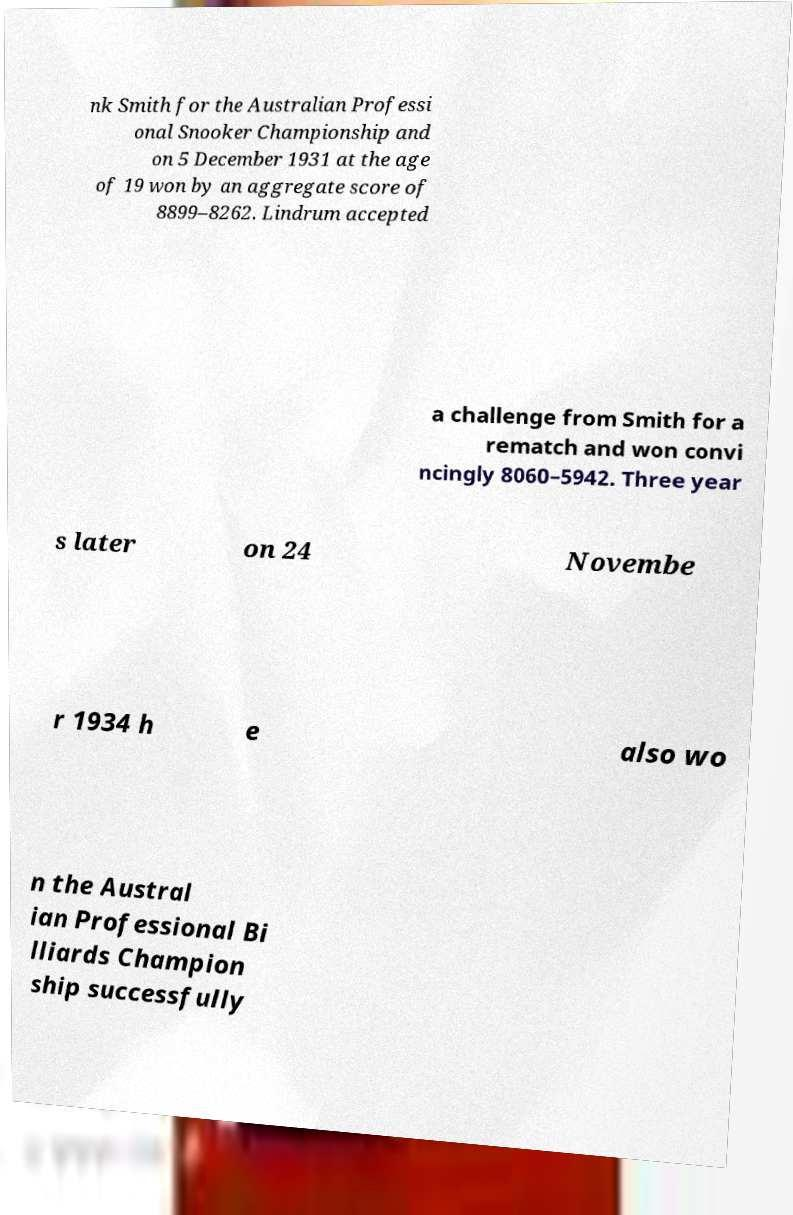Please identify and transcribe the text found in this image. nk Smith for the Australian Professi onal Snooker Championship and on 5 December 1931 at the age of 19 won by an aggregate score of 8899–8262. Lindrum accepted a challenge from Smith for a rematch and won convi ncingly 8060–5942. Three year s later on 24 Novembe r 1934 h e also wo n the Austral ian Professional Bi lliards Champion ship successfully 